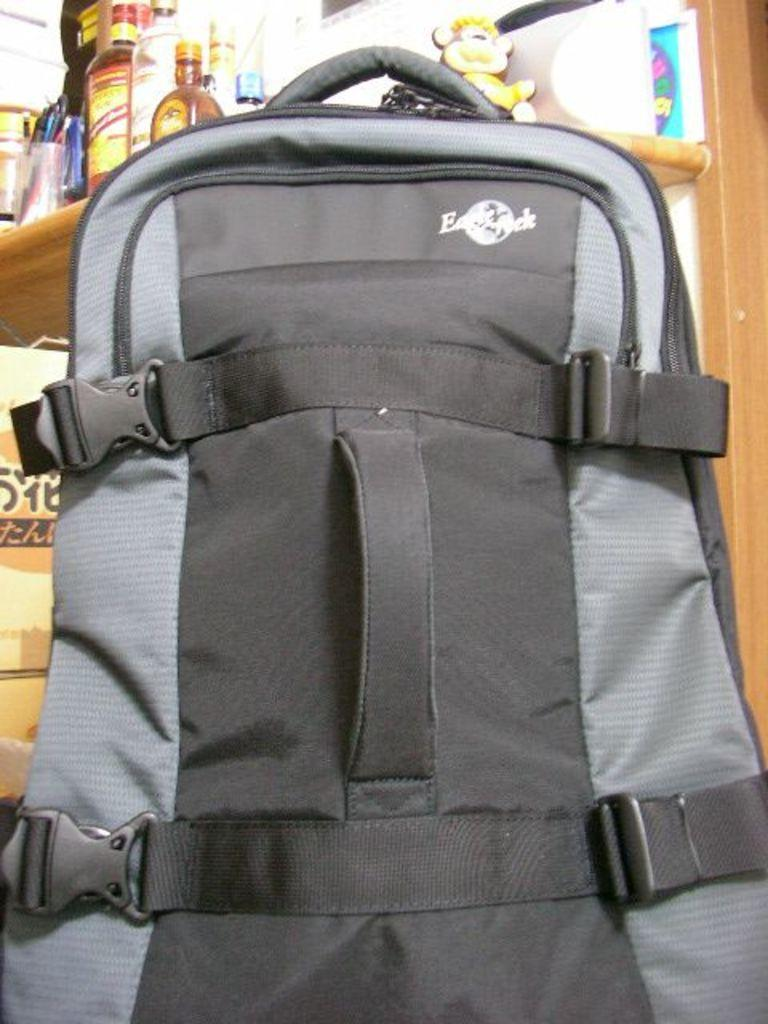What object is visible in the image that people might use for carrying items? There is a backpack in the image that people might use for carrying items. What colors are present on the backpack? The backpack is black and ash in color. What is located behind the backpack in the image? There is a shelf behind the backpack. What two items can be seen on the shelf? There is a bottle and a toy on the shelf. What type of story is being told by the train in the image? There is no train present in the image, so no story is being told by a train. 